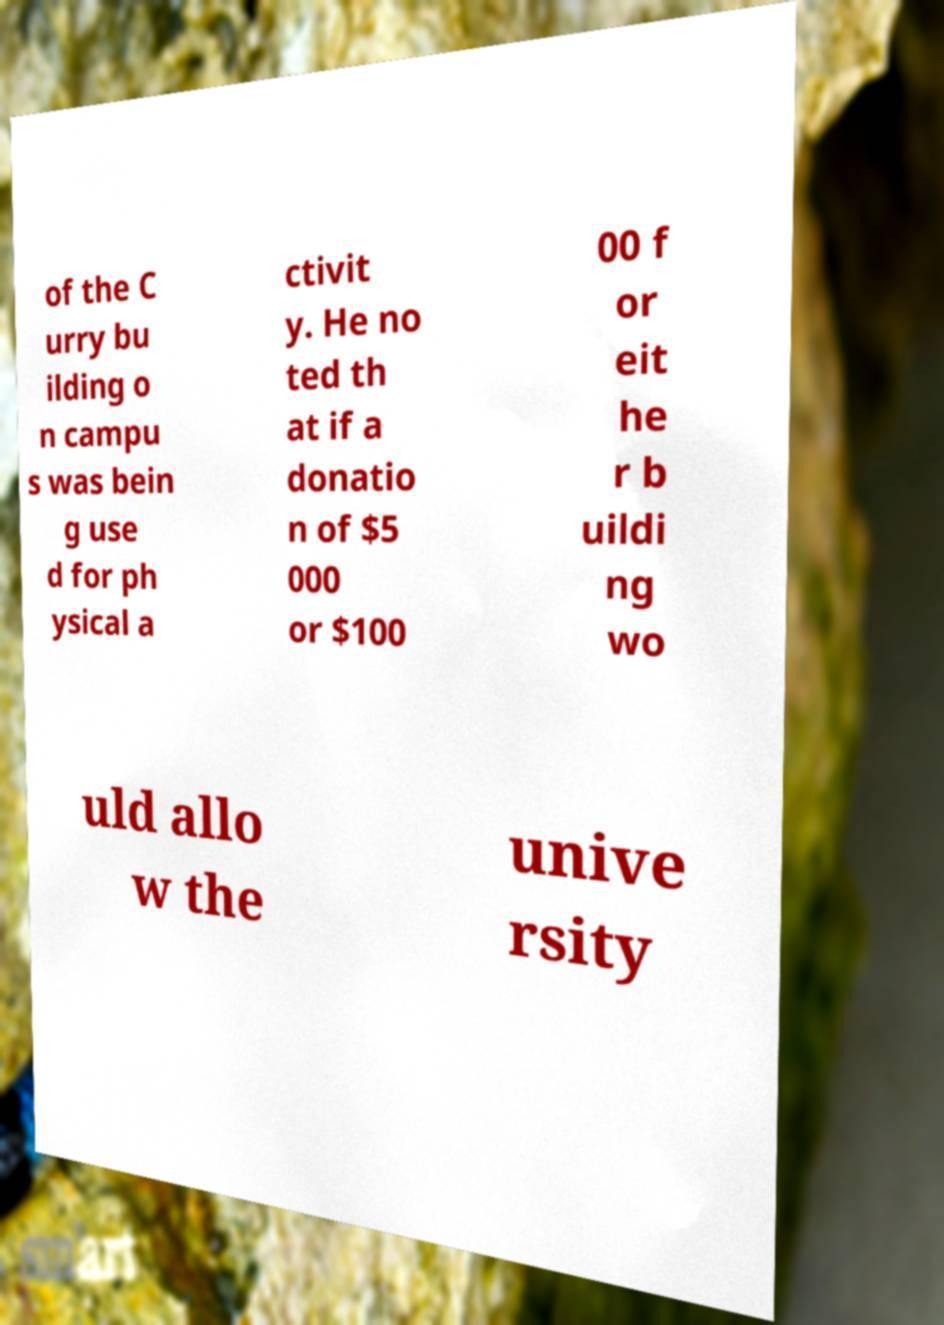Could you extract and type out the text from this image? of the C urry bu ilding o n campu s was bein g use d for ph ysical a ctivit y. He no ted th at if a donatio n of $5 000 or $100 00 f or eit he r b uildi ng wo uld allo w the unive rsity 